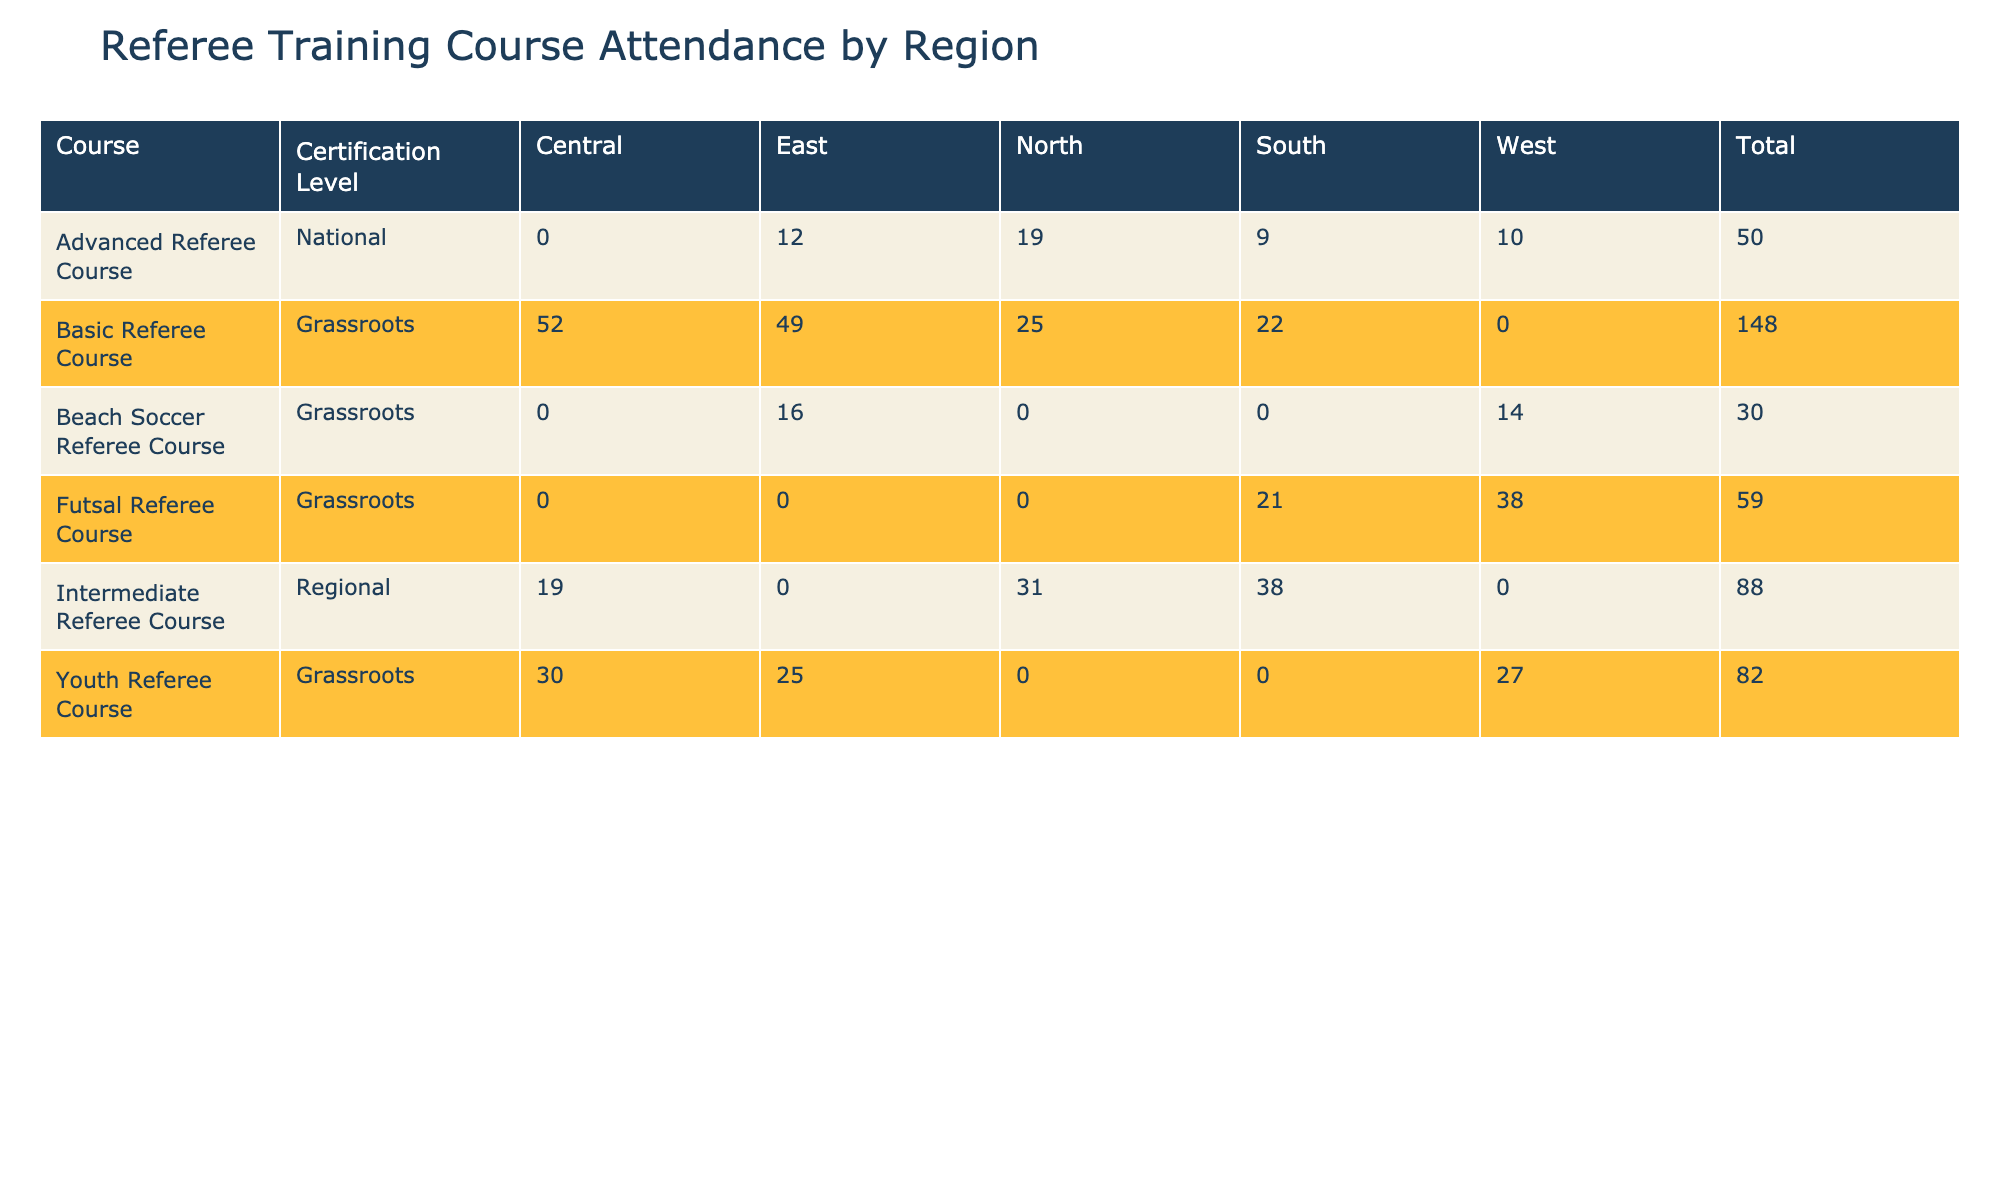What course had the highest attendance in the South region? Looking at the South region, the "Basic Referee Course" in June has the highest attendance with 22 attendees.
Answer: Basic Referee Course How many attendees passed the Advanced Referee Courses in total? The total number of attendees who passed the Advanced Referee Courses can be summed from the three months: March (10), August (8), and December (7). So, 10 + 8 + 7 equals 25.
Answer: 25 Did the Youth Referee Course in May have more attendees than in November? In May, the Youth Referee Course had 30 attendees, while in November it had 27. Since 30 is greater than 27, it is true.
Answer: Yes What was the average number of attendees for the Basic Referee Course in the East region? The Basic Referee Course had three entries in the East region with attendance numbers of December (23), March (24), and July (26). Adding them gives 23 + 24 + 26 equals 73. Dividing by 3 gives an average of 73/3, which is approximately 24.33.
Answer: 24.33 Which region had the lowest total attendance across all courses? To find the region with the lowest total attendance, we sum attendance figures for each region: North (40), South (70), East (35), Central (52), and West (66). North has the lowest total of 40.
Answer: North 